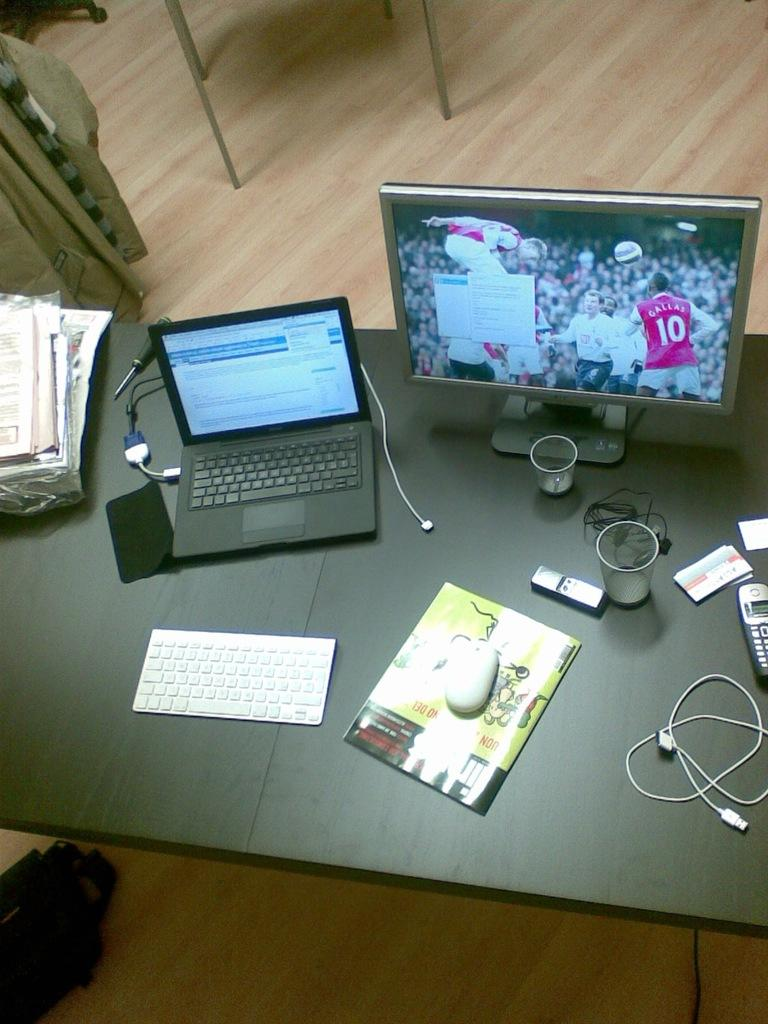<image>
Provide a brief description of the given image. An overhead shot of a desk where the desktop screen has a shot of a player in a red jersey wearing number 10. 